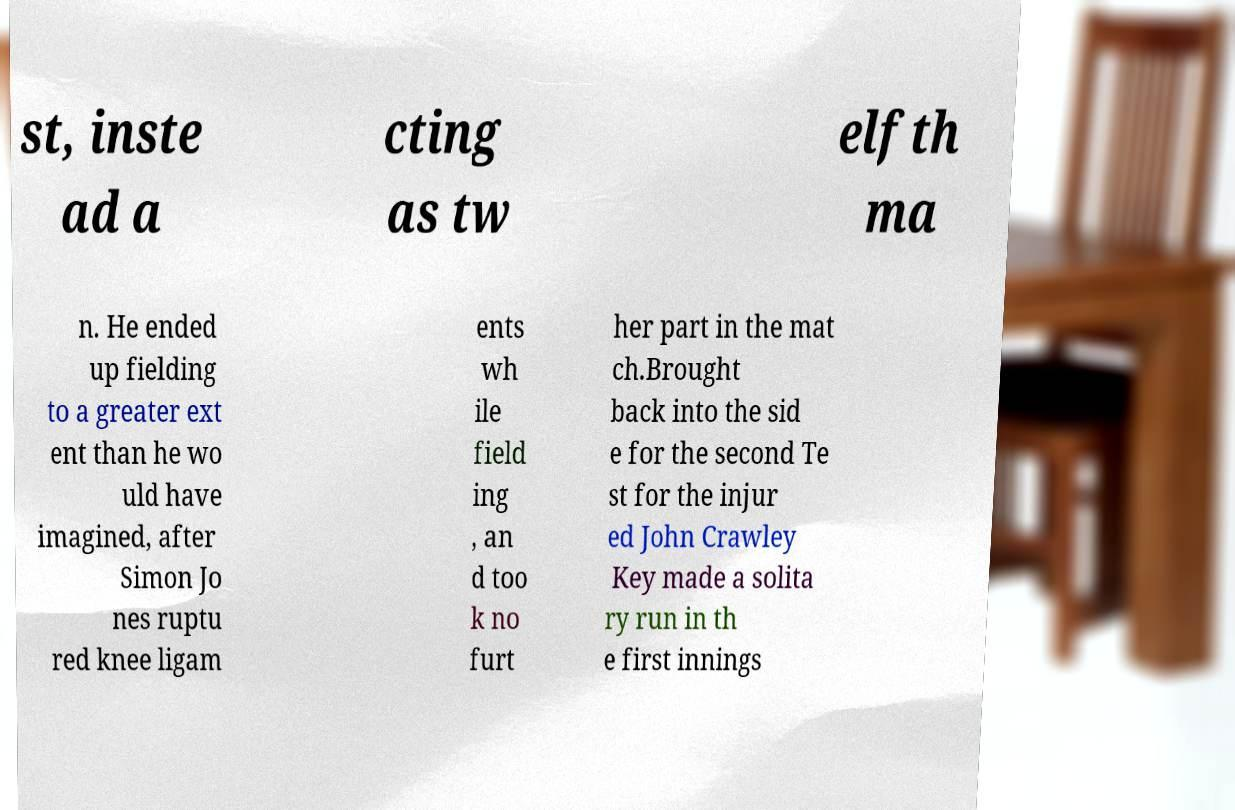Can you accurately transcribe the text from the provided image for me? st, inste ad a cting as tw elfth ma n. He ended up fielding to a greater ext ent than he wo uld have imagined, after Simon Jo nes ruptu red knee ligam ents wh ile field ing , an d too k no furt her part in the mat ch.Brought back into the sid e for the second Te st for the injur ed John Crawley Key made a solita ry run in th e first innings 